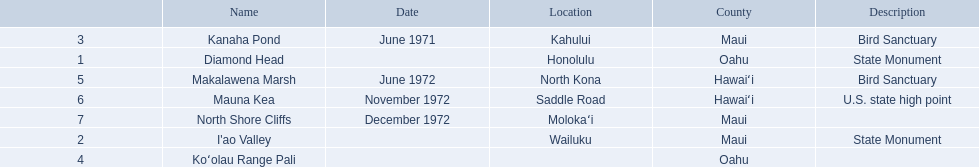What are all of the landmark names in hawaii? Diamond Head, I'ao Valley, Kanaha Pond, Koʻolau Range Pali, Makalawena Marsh, Mauna Kea, North Shore Cliffs. What are their descriptions? State Monument, State Monument, Bird Sanctuary, , Bird Sanctuary, U.S. state high point, . And which is described as a u.s. state high point? Mauna Kea. 